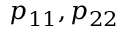Convert formula to latex. <formula><loc_0><loc_0><loc_500><loc_500>p _ { 1 1 } , p _ { 2 2 }</formula> 